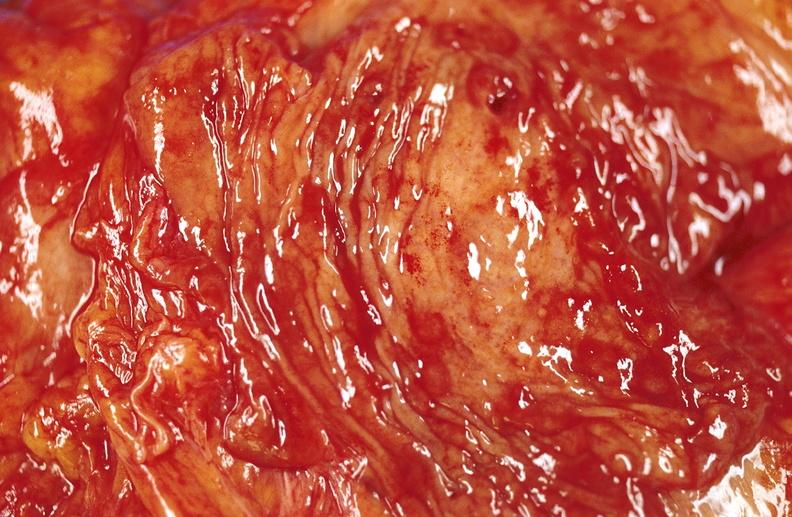s gastrointestinal present?
Answer the question using a single word or phrase. Yes 